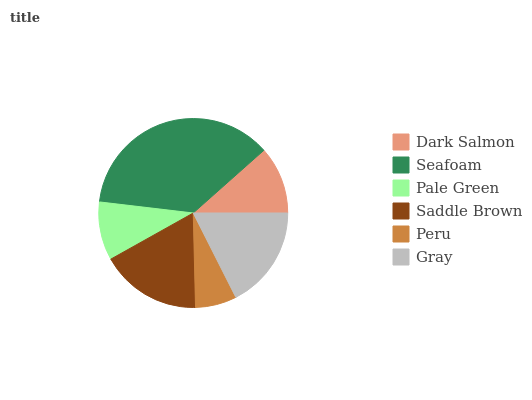Is Peru the minimum?
Answer yes or no. Yes. Is Seafoam the maximum?
Answer yes or no. Yes. Is Pale Green the minimum?
Answer yes or no. No. Is Pale Green the maximum?
Answer yes or no. No. Is Seafoam greater than Pale Green?
Answer yes or no. Yes. Is Pale Green less than Seafoam?
Answer yes or no. Yes. Is Pale Green greater than Seafoam?
Answer yes or no. No. Is Seafoam less than Pale Green?
Answer yes or no. No. Is Saddle Brown the high median?
Answer yes or no. Yes. Is Dark Salmon the low median?
Answer yes or no. Yes. Is Dark Salmon the high median?
Answer yes or no. No. Is Gray the low median?
Answer yes or no. No. 